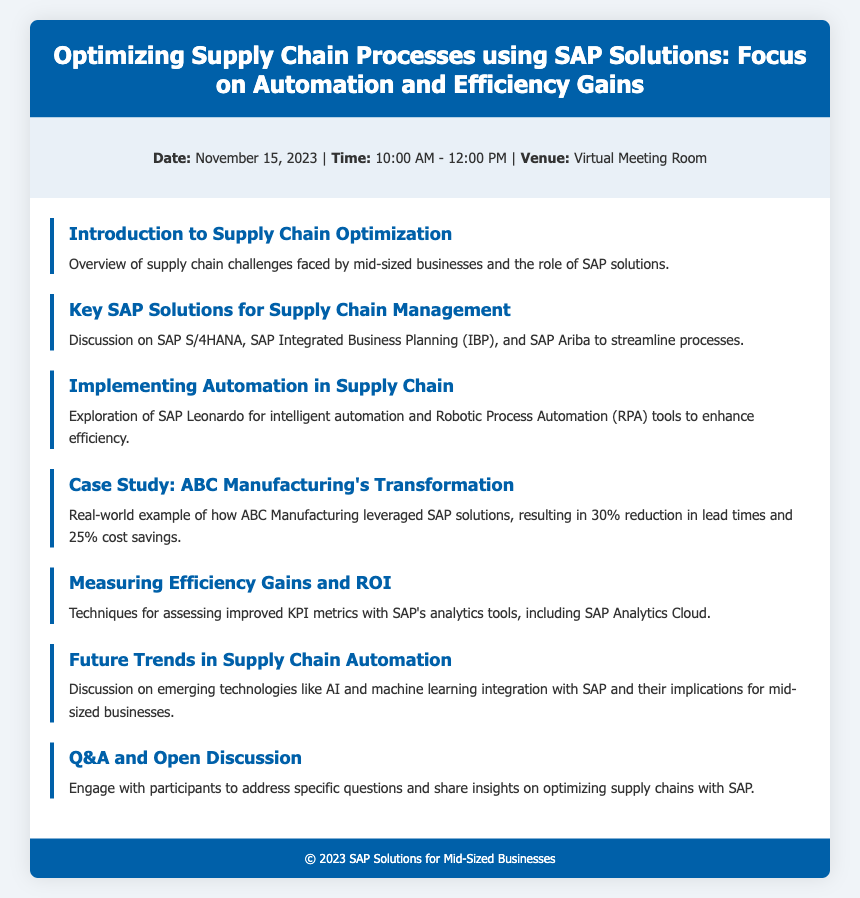What is the date of the event? The date of the event is mentioned in the event details section of the document.
Answer: November 15, 2023 What time does the event start? The time is specified in the event details section.
Answer: 10:00 AM What is the main focus of the agenda? The title of the agenda clearly indicates the main focus.
Answer: Automation and Efficiency Gains What is one key SAP solution discussed for supply chain management? The agenda item specifically lists several SAP solutions relevant to supply chain management.
Answer: SAP S/4HANA What was the lead time reduction achieved by ABC Manufacturing? This metric is given in the case study section of the agenda.
Answer: 30% Which SAP tool is mentioned for measuring efficiency gains? The agenda includes techniques for assessing KPI metrics with specific tools.
Answer: SAP Analytics Cloud What is the format of the event? The venue details provided in the document clarify the event format.
Answer: Virtual Meeting Room What emerging technologies are discussed in relation to future trends? The agenda item covers future trends and mentions specific technologies.
Answer: AI and machine learning 